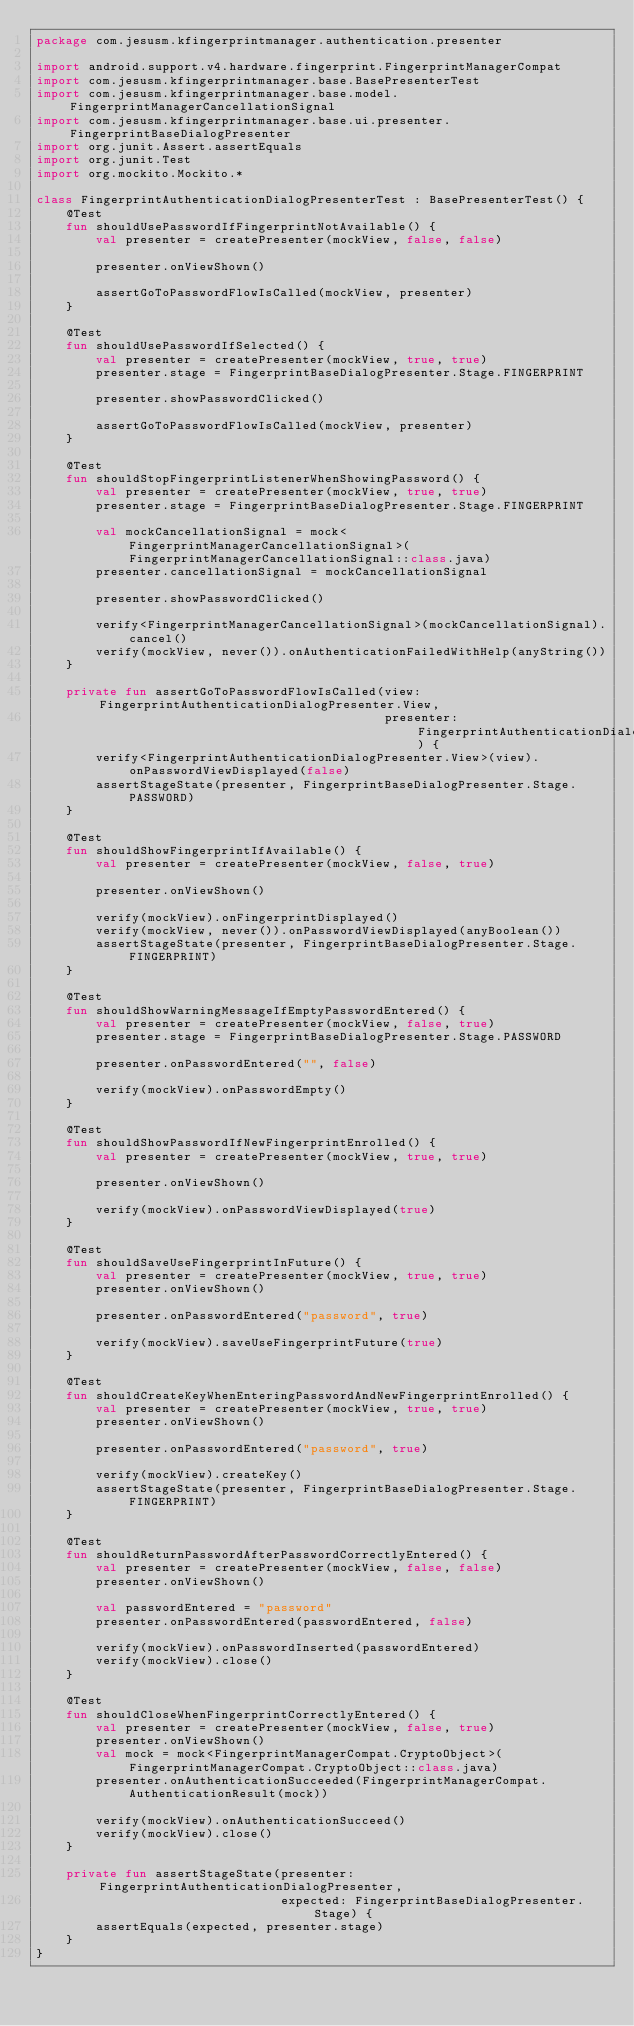Convert code to text. <code><loc_0><loc_0><loc_500><loc_500><_Kotlin_>package com.jesusm.kfingerprintmanager.authentication.presenter

import android.support.v4.hardware.fingerprint.FingerprintManagerCompat
import com.jesusm.kfingerprintmanager.base.BasePresenterTest
import com.jesusm.kfingerprintmanager.base.model.FingerprintManagerCancellationSignal
import com.jesusm.kfingerprintmanager.base.ui.presenter.FingerprintBaseDialogPresenter
import org.junit.Assert.assertEquals
import org.junit.Test
import org.mockito.Mockito.*

class FingerprintAuthenticationDialogPresenterTest : BasePresenterTest() {
    @Test
    fun shouldUsePasswordIfFingerprintNotAvailable() {
        val presenter = createPresenter(mockView, false, false)

        presenter.onViewShown()

        assertGoToPasswordFlowIsCalled(mockView, presenter)
    }

    @Test
    fun shouldUsePasswordIfSelected() {
        val presenter = createPresenter(mockView, true, true)
        presenter.stage = FingerprintBaseDialogPresenter.Stage.FINGERPRINT

        presenter.showPasswordClicked()

        assertGoToPasswordFlowIsCalled(mockView, presenter)
    }

    @Test
    fun shouldStopFingerprintListenerWhenShowingPassword() {
        val presenter = createPresenter(mockView, true, true)
        presenter.stage = FingerprintBaseDialogPresenter.Stage.FINGERPRINT

        val mockCancellationSignal = mock<FingerprintManagerCancellationSignal>(FingerprintManagerCancellationSignal::class.java)
        presenter.cancellationSignal = mockCancellationSignal

        presenter.showPasswordClicked()

        verify<FingerprintManagerCancellationSignal>(mockCancellationSignal).cancel()
        verify(mockView, never()).onAuthenticationFailedWithHelp(anyString())
    }

    private fun assertGoToPasswordFlowIsCalled(view: FingerprintAuthenticationDialogPresenter.View,
                                               presenter: FingerprintAuthenticationDialogPresenter) {
        verify<FingerprintAuthenticationDialogPresenter.View>(view).onPasswordViewDisplayed(false)
        assertStageState(presenter, FingerprintBaseDialogPresenter.Stage.PASSWORD)
    }

    @Test
    fun shouldShowFingerprintIfAvailable() {
        val presenter = createPresenter(mockView, false, true)

        presenter.onViewShown()

        verify(mockView).onFingerprintDisplayed()
        verify(mockView, never()).onPasswordViewDisplayed(anyBoolean())
        assertStageState(presenter, FingerprintBaseDialogPresenter.Stage.FINGERPRINT)
    }

    @Test
    fun shouldShowWarningMessageIfEmptyPasswordEntered() {
        val presenter = createPresenter(mockView, false, true)
        presenter.stage = FingerprintBaseDialogPresenter.Stage.PASSWORD

        presenter.onPasswordEntered("", false)

        verify(mockView).onPasswordEmpty()
    }

    @Test
    fun shouldShowPasswordIfNewFingerprintEnrolled() {
        val presenter = createPresenter(mockView, true, true)

        presenter.onViewShown()

        verify(mockView).onPasswordViewDisplayed(true)
    }

    @Test
    fun shouldSaveUseFingerprintInFuture() {
        val presenter = createPresenter(mockView, true, true)
        presenter.onViewShown()

        presenter.onPasswordEntered("password", true)

        verify(mockView).saveUseFingerprintFuture(true)
    }

    @Test
    fun shouldCreateKeyWhenEnteringPasswordAndNewFingerprintEnrolled() {
        val presenter = createPresenter(mockView, true, true)
        presenter.onViewShown()

        presenter.onPasswordEntered("password", true)

        verify(mockView).createKey()
        assertStageState(presenter, FingerprintBaseDialogPresenter.Stage.FINGERPRINT)
    }

    @Test
    fun shouldReturnPasswordAfterPasswordCorrectlyEntered() {
        val presenter = createPresenter(mockView, false, false)
        presenter.onViewShown()

        val passwordEntered = "password"
        presenter.onPasswordEntered(passwordEntered, false)

        verify(mockView).onPasswordInserted(passwordEntered)
        verify(mockView).close()
    }

    @Test
    fun shouldCloseWhenFingerprintCorrectlyEntered() {
        val presenter = createPresenter(mockView, false, true)
        presenter.onViewShown()
        val mock = mock<FingerprintManagerCompat.CryptoObject>(FingerprintManagerCompat.CryptoObject::class.java)
        presenter.onAuthenticationSucceeded(FingerprintManagerCompat.AuthenticationResult(mock))

        verify(mockView).onAuthenticationSucceed()
        verify(mockView).close()
    }

    private fun assertStageState(presenter: FingerprintAuthenticationDialogPresenter,
                                 expected: FingerprintBaseDialogPresenter.Stage) {
        assertEquals(expected, presenter.stage)
    }
}</code> 